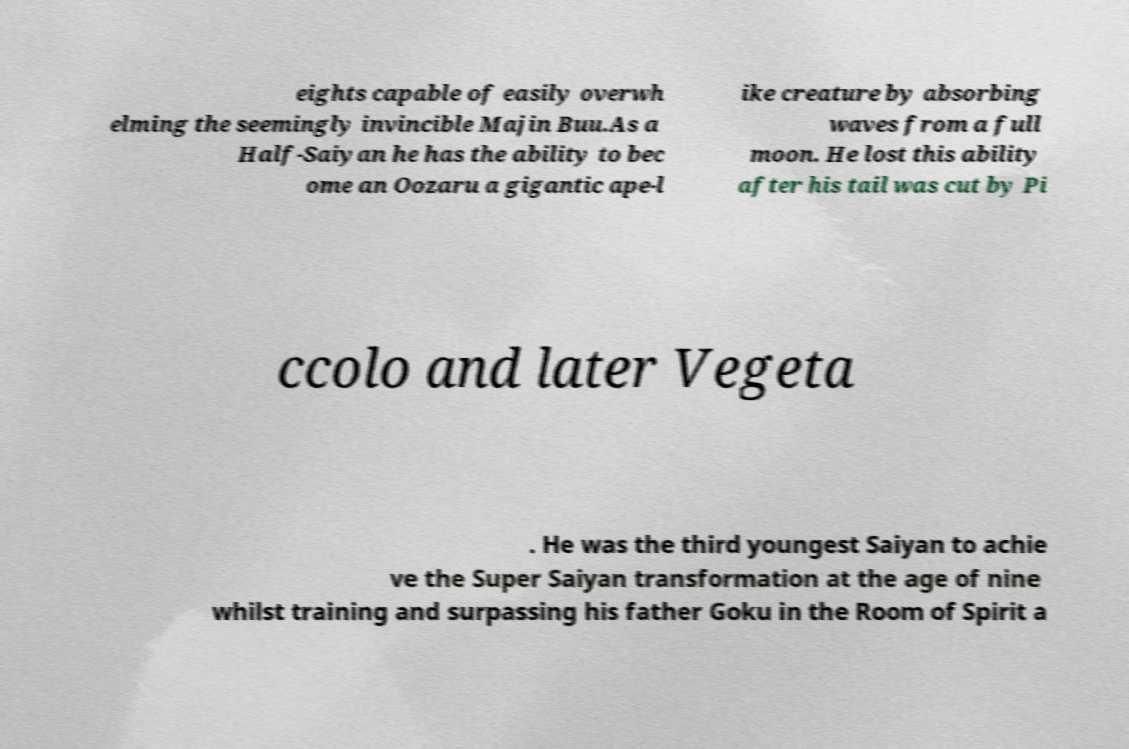I need the written content from this picture converted into text. Can you do that? eights capable of easily overwh elming the seemingly invincible Majin Buu.As a Half-Saiyan he has the ability to bec ome an Oozaru a gigantic ape-l ike creature by absorbing waves from a full moon. He lost this ability after his tail was cut by Pi ccolo and later Vegeta . He was the third youngest Saiyan to achie ve the Super Saiyan transformation at the age of nine whilst training and surpassing his father Goku in the Room of Spirit a 